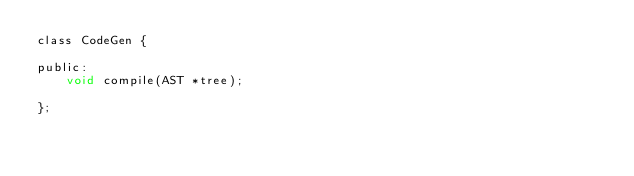Convert code to text. <code><loc_0><loc_0><loc_500><loc_500><_C_>class CodeGen {

public:
    void compile(AST *tree);

};</code> 